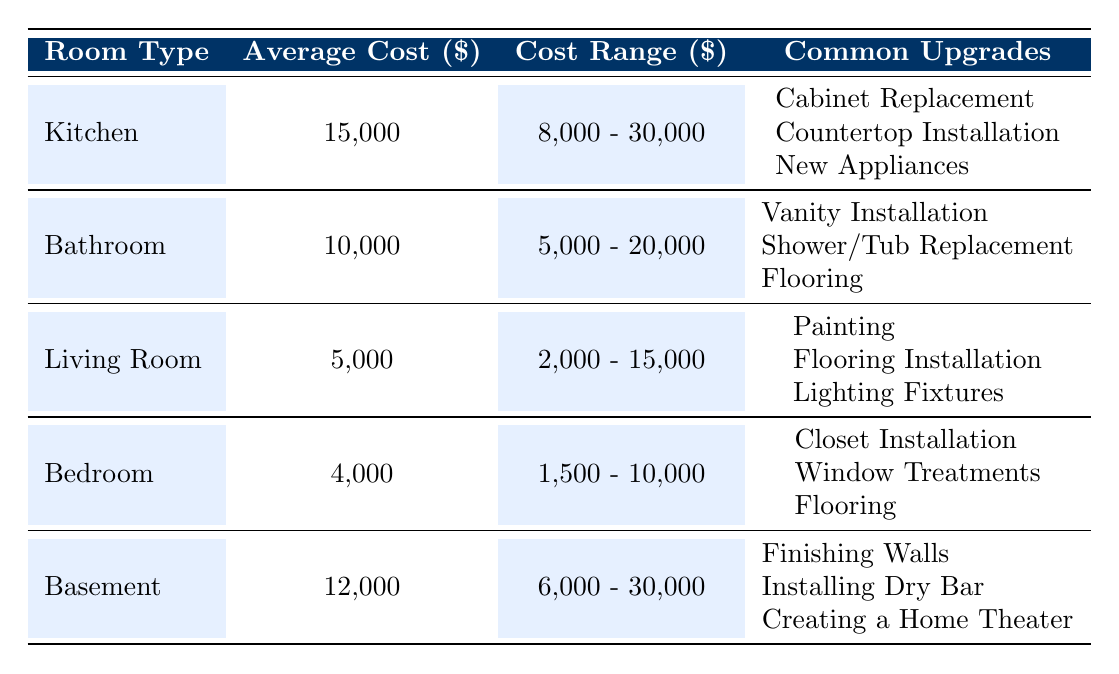What is the average cost to renovate a bathroom? The average cost for a bathroom renovation is directly provided in the table under the "Average Cost" column for the Bathroom row, which is 10,000 dollars.
Answer: 10,000 Which room type has the highest average renovation cost? By comparing the "Average Cost" values in the table, the Kitchen has the highest average renovation cost of 15,000 dollars, followed by the Basement at 12,000 dollars.
Answer: Kitchen What is the total cost range for renovating a living room? The cost range for the Living Room is provided as 2,000 to 15,000 dollars. Therefore, the total cost range is calculated based on those values, but it requires no math outside of retrieving the provided values from the table.
Answer: 2,000 - 15,000 Is it true that renovating a bedroom costs less than renovating a bathroom? To determine this, we compare the average costs for both rooms. The average cost to renovate a bedroom is 4,000 dollars, while for a bathroom, it is 10,000 dollars, confirming that the bedroom is indeed less costly.
Answer: Yes What is the difference in average renovation costs between the Kitchen and Bedroom? The average cost for the Kitchen is 15,000 dollars, while for the Bedroom it is 4,000 dollars. The difference can be calculated as 15,000 - 4,000 which equals 11,000 dollars.
Answer: 11,000 Which common upgrade is associated with a basement renovation? The table lists common upgrades for the Basement, which include "Finishing Walls," "Installing Dry Bar," and "Creating a Home Theater." Thus, any of these can be considered.
Answer: Finishing Walls, Installing Dry Bar, Creating a Home Theater Do the common upgrades for the Living Room include flooring installation? According to the table under the Living Room row, "Flooring Installation" is listed among the common upgrades, thus confirming that it does.
Answer: Yes How many room types have an average cost over 10,000 dollars? By examining the average costs listed in the table, only the Kitchen and Basement have average renovation costs exceeding 10,000 dollars. Thus, we conclude there are two such room types.
Answer: 2 What is the highest possible renovation cost for a bathroom? The highest renovation cost for a bathroom is provided in the "Cost Range" of the Bathroom row as 20,000 dollars. Hence, this value indicates the maximum expenditure expected for a bathroom renovation.
Answer: 20,000 